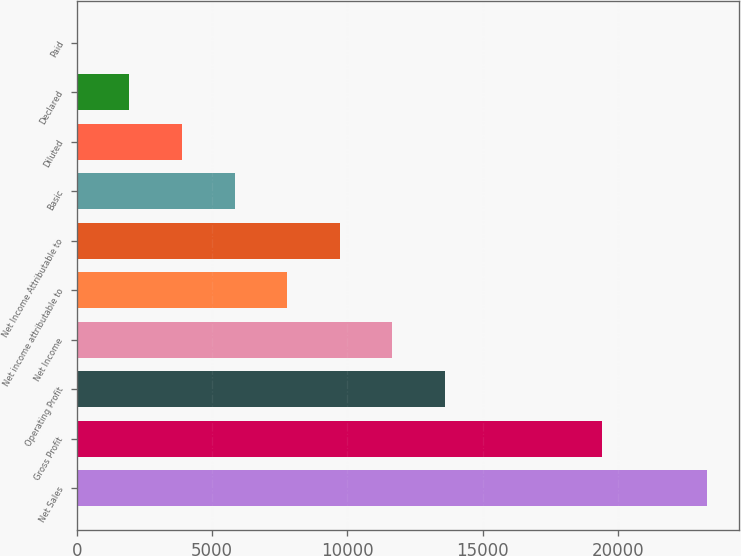<chart> <loc_0><loc_0><loc_500><loc_500><bar_chart><fcel>Net Sales<fcel>Gross Profit<fcel>Operating Profit<fcel>Net Income<fcel>Net income attributable to<fcel>Net Income Attributable to<fcel>Basic<fcel>Diluted<fcel>Declared<fcel>Paid<nl><fcel>23297.5<fcel>19415<fcel>13591.2<fcel>11649.9<fcel>7767.35<fcel>9708.62<fcel>5826.08<fcel>3884.81<fcel>1943.54<fcel>2.27<nl></chart> 